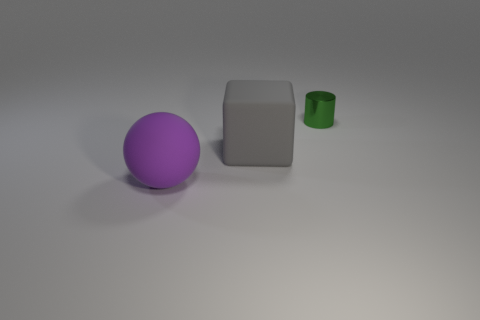Are there fewer tiny green metallic things that are on the right side of the large purple rubber sphere than big gray matte blocks?
Offer a very short reply. No. Are there any other green metal cylinders that have the same size as the shiny cylinder?
Give a very brief answer. No. What is the color of the cube that is made of the same material as the purple thing?
Your answer should be compact. Gray. What number of large rubber balls are in front of the green cylinder on the right side of the gray thing?
Your answer should be very brief. 1. There is a thing that is left of the shiny object and to the right of the ball; what is it made of?
Your response must be concise. Rubber. There is a big rubber thing to the right of the purple rubber ball; is it the same shape as the shiny thing?
Offer a very short reply. No. Is the number of tiny gray rubber balls less than the number of shiny cylinders?
Give a very brief answer. Yes. What number of big matte cubes have the same color as the ball?
Your answer should be very brief. 0. Is the color of the large matte ball the same as the matte thing that is behind the purple matte sphere?
Your response must be concise. No. Are there more purple spheres than big brown things?
Provide a short and direct response. Yes. 